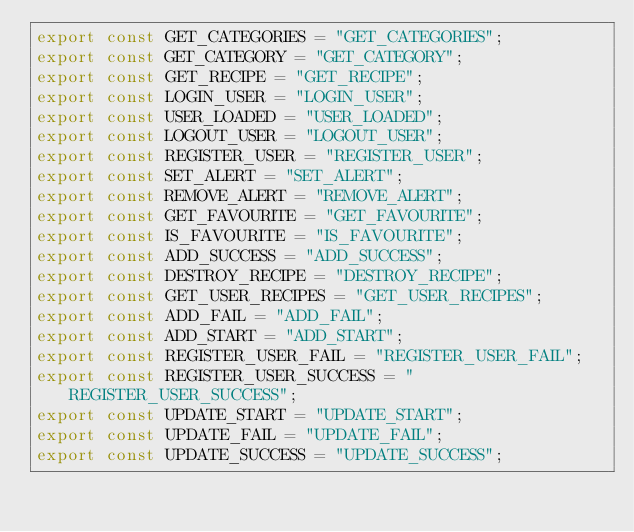Convert code to text. <code><loc_0><loc_0><loc_500><loc_500><_JavaScript_>export const GET_CATEGORIES = "GET_CATEGORIES";
export const GET_CATEGORY = "GET_CATEGORY";
export const GET_RECIPE = "GET_RECIPE";
export const LOGIN_USER = "LOGIN_USER";
export const USER_LOADED = "USER_LOADED";
export const LOGOUT_USER = "LOGOUT_USER";
export const REGISTER_USER = "REGISTER_USER";
export const SET_ALERT = "SET_ALERT";
export const REMOVE_ALERT = "REMOVE_ALERT";
export const GET_FAVOURITE = "GET_FAVOURITE";
export const IS_FAVOURITE = "IS_FAVOURITE";
export const ADD_SUCCESS = "ADD_SUCCESS";
export const DESTROY_RECIPE = "DESTROY_RECIPE";
export const GET_USER_RECIPES = "GET_USER_RECIPES";
export const ADD_FAIL = "ADD_FAIL";
export const ADD_START = "ADD_START";
export const REGISTER_USER_FAIL = "REGISTER_USER_FAIL";
export const REGISTER_USER_SUCCESS = "REGISTER_USER_SUCCESS";
export const UPDATE_START = "UPDATE_START";
export const UPDATE_FAIL = "UPDATE_FAIL";
export const UPDATE_SUCCESS = "UPDATE_SUCCESS";
</code> 